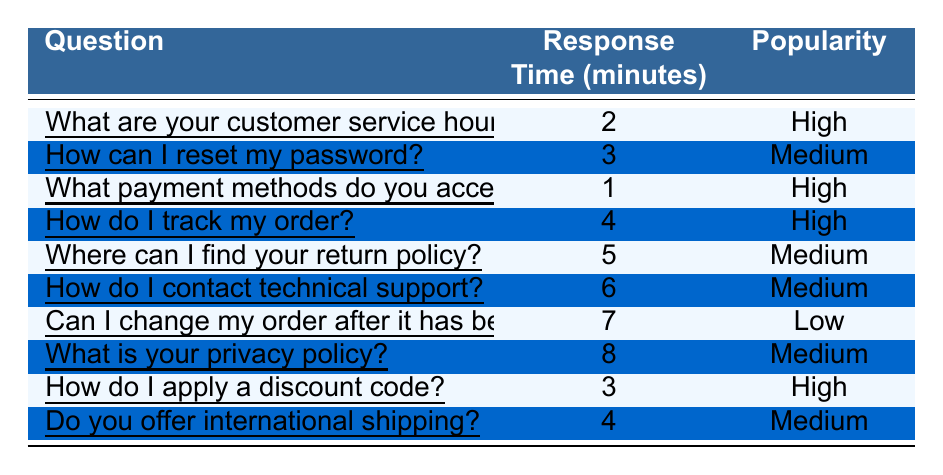What is the response time for resetting a password? The response time for the question "How can I reset my password?" is directly listed in the table under the "Response Time (minutes)" column. It shows 3 minutes.
Answer: 3 minutes Which question has the shortest response time? The questions listed in the table are compared based on their response times. "What payment methods do you accept?" has the shortest response time of 1 minute.
Answer: What payment methods do you accept? How many questions have a high popularity rating? The table can be scanned for questions marked with "High" in the "Popularity" column. There are 4 such questions, which are: "What are your customer service hours?", "What payment methods do you accept?", "How do I track my order?", and "How do I apply a discount code?".
Answer: 4 questions Is the response time for contacting technical support shorter than for finding the return policy? By comparing the response time for "How do I contact technical support?" which is 6 minutes, with the response time for "Where can I find your return policy?" which is 5 minutes, we find that 6 is greater than 5, so it is false.
Answer: No What is the average response time for questions with medium popularity? First, we identify the questions with a medium popularity rating and their respective response times: 3 (reset password), 5 (return policy), 6 (contact support), 8 (privacy policy). Next, we sum these times: 3 + 5 + 6 + 8 = 22. There are 4 data points, so we divide the sum by 4: 22/4 = 5.5.
Answer: 5.5 minutes Which question takes the longest to get a response, and what is the response time? From the table, comparing all response times, "What is your privacy policy?" has the longest response time of 8 minutes.
Answer: What is your privacy policy? and 8 minutes Do you accept credit cards as a payment method? The table does not provide specific payment methods accepted. Therefore, it can't be answered yes or no based on the given data.
Answer: No If a customer wants to know about international shipping, how long would they wait on average based on the relevant response time from the table? The table shows "Do you offer international shipping?" takes 4 minutes for a response. Therefore, the average wait time for that specific question is simply 4 minutes.
Answer: 4 minutes Are more questions about payment methods categorized as high popularity compared to those about return policies? From the table, there are 3 questions related to payments where popularity is high: "What payment methods do you accept?" and "How do I apply a discount code?". In contrast, there is only 1 question about return policy that has medium popularity: "Where can I find your return policy?". Hence, more questions related to payment are high popularity.
Answer: Yes 